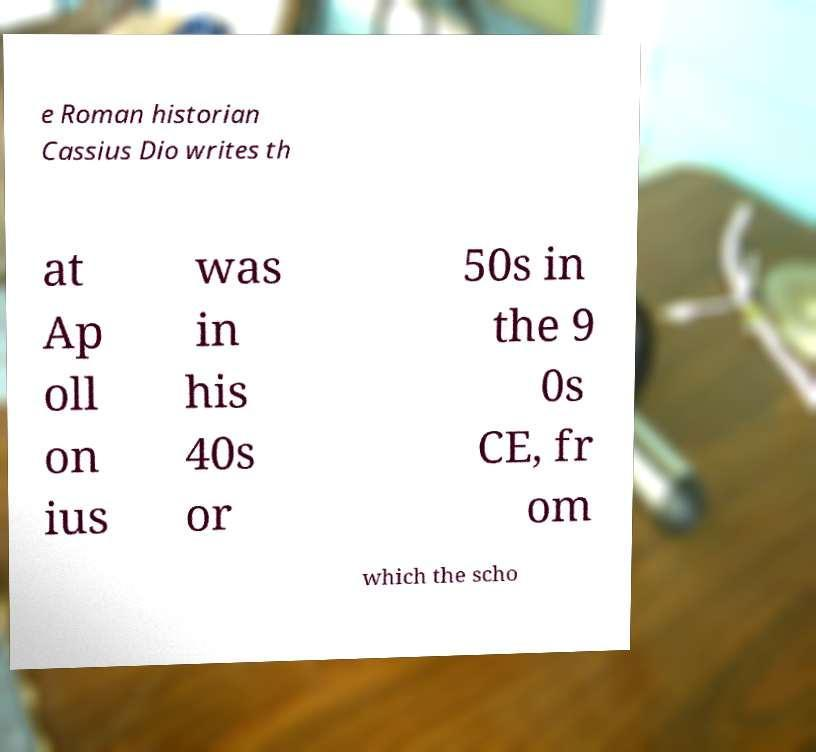Can you accurately transcribe the text from the provided image for me? e Roman historian Cassius Dio writes th at Ap oll on ius was in his 40s or 50s in the 9 0s CE, fr om which the scho 